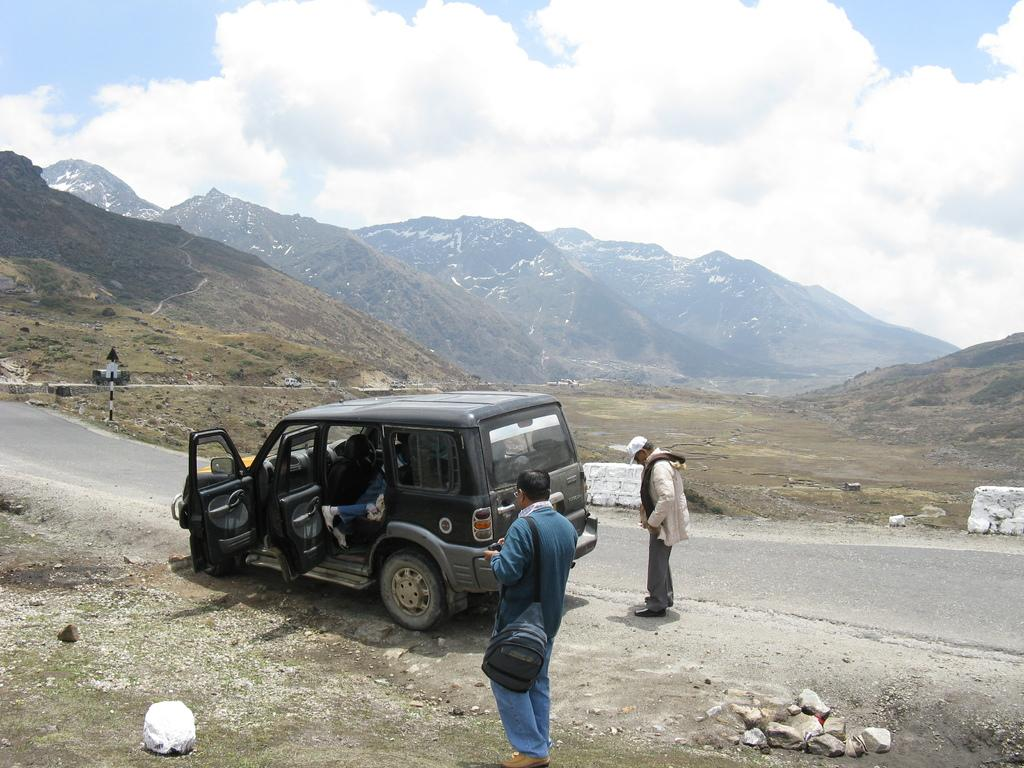What is happening in the image? There are persons standing in the image. What are the persons wearing? The persons are wearing clothes. What can be seen on the road in the image? There is a vehicle on the road in the image. What type of natural feature is in the middle of the image? There are hills in the middle of the image. What is visible at the top of the image? The sky is visible at the top of the image. How many geese are playing with the ball in the image? There are no geese or ball present in the image. What are the boys doing in the image? The provided facts do not mention any boys in the image, so we cannot answer this question. 